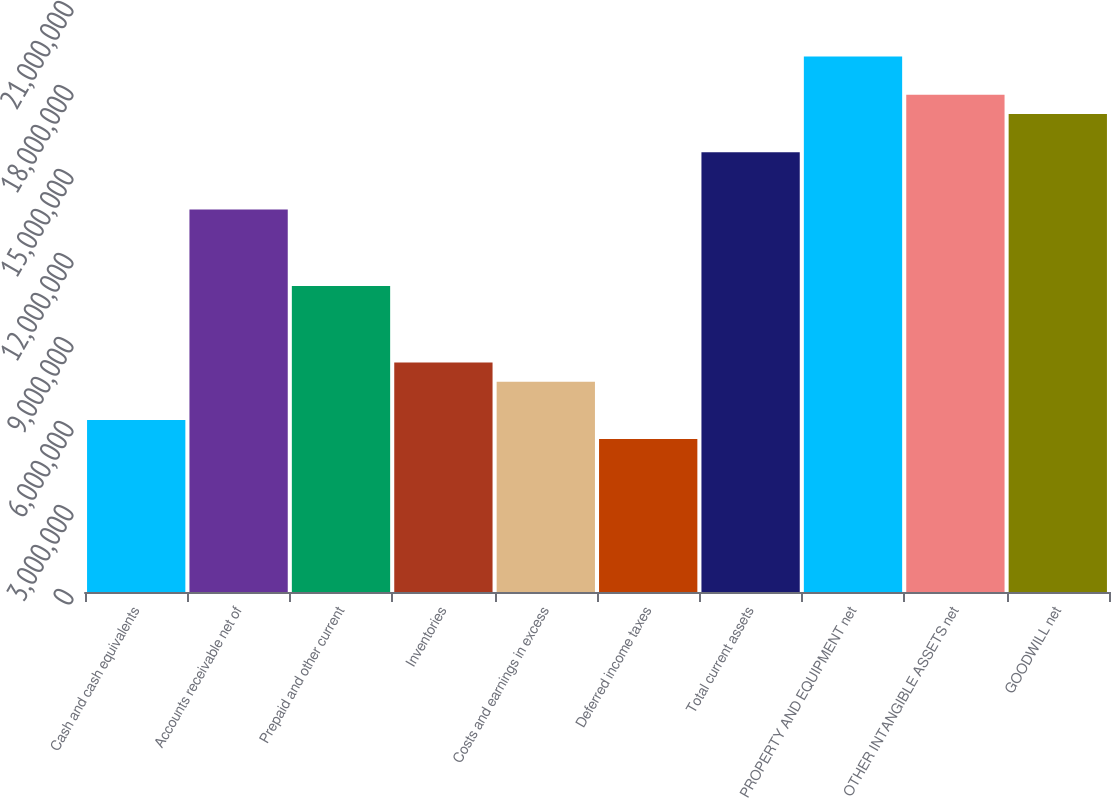Convert chart. <chart><loc_0><loc_0><loc_500><loc_500><bar_chart><fcel>Cash and cash equivalents<fcel>Accounts receivable net of<fcel>Prepaid and other current<fcel>Inventories<fcel>Costs and earnings in excess<fcel>Deferred income taxes<fcel>Total current assets<fcel>PROPERTY AND EQUIPMENT net<fcel>OTHER INTANGIBLE ASSETS net<fcel>GOODWILL net<nl><fcel>6.14675e+06<fcel>1.36594e+07<fcel>1.09275e+07<fcel>8.19566e+06<fcel>7.51269e+06<fcel>5.46378e+06<fcel>1.57083e+07<fcel>1.91232e+07<fcel>1.77572e+07<fcel>1.70743e+07<nl></chart> 